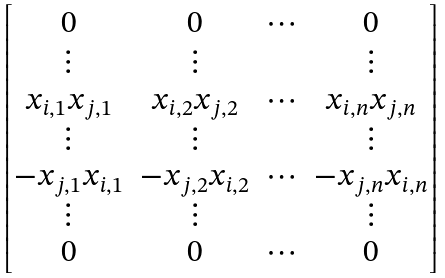Convert formula to latex. <formula><loc_0><loc_0><loc_500><loc_500>\begin{bmatrix} 0 & 0 & \cdots & 0 \\ \vdots & \vdots & & \vdots \\ x _ { i , 1 } x _ { j , 1 } & x _ { i , 2 } x _ { j , 2 } & \cdots & x _ { i , n } x _ { j , n } \\ \vdots & \vdots & & \vdots \\ - x _ { j , 1 } x _ { i , 1 } & - x _ { j , 2 } x _ { i , 2 } & \cdots & - x _ { j , n } x _ { i , n } \\ \vdots & \vdots & & \vdots \\ 0 & 0 & \cdots & 0 \end{bmatrix}</formula> 